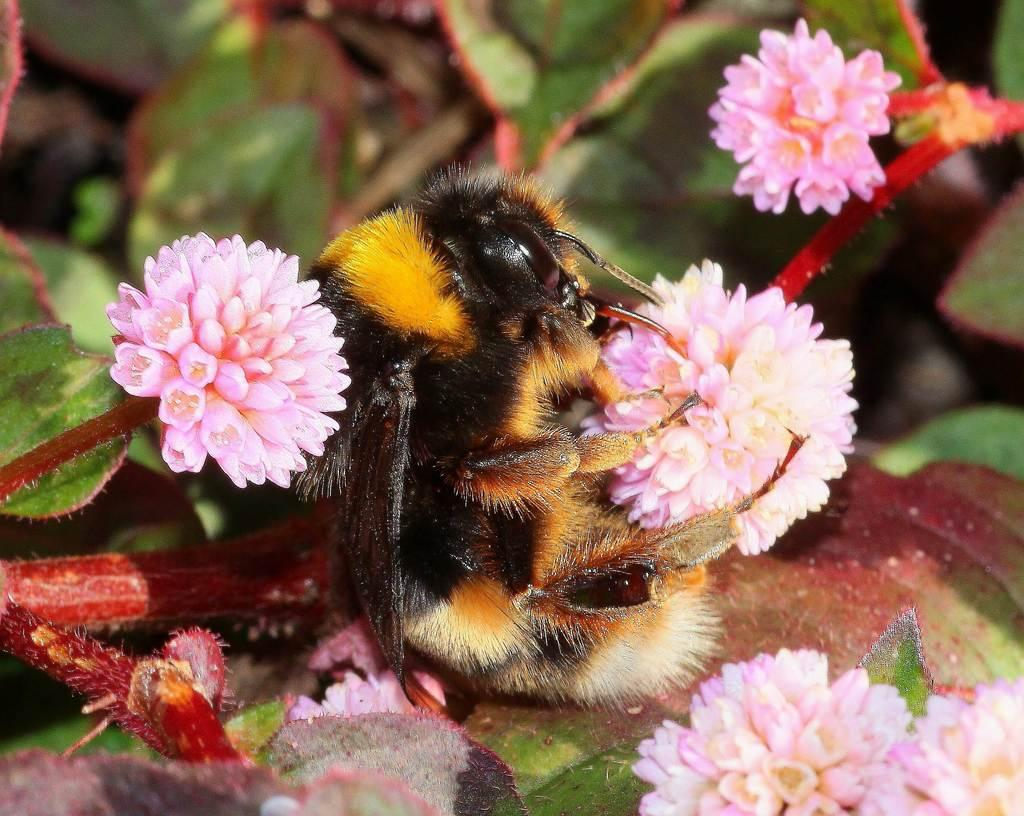What type of creature can be seen in the image? There is an insect in the image. What type of plants are present in the image? There are flowers, leaves, and stems in the image. What is the background of the image like? The background of the image is blurry. What type of arch can be seen in the image? There is no arch present in the image. How does the insect rub its legs together in the image? The image does not show the insect rubbing its legs together; it only shows the insect itself. 